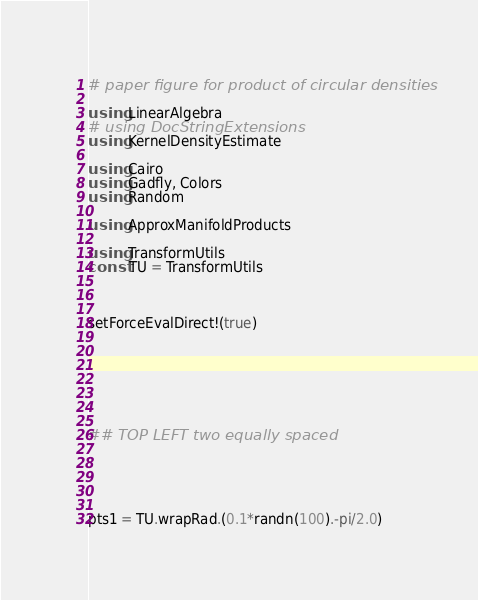Convert code to text. <code><loc_0><loc_0><loc_500><loc_500><_Julia_># paper figure for product of circular densities

using LinearAlgebra
# using DocStringExtensions
using KernelDensityEstimate

using Cairo
using Gadfly, Colors
using Random

using ApproxManifoldProducts

using TransformUtils
const TU = TransformUtils



setForceEvalDirect!(true)







## TOP LEFT two equally spaced





pts1 = TU.wrapRad.(0.1*randn(100).-pi/2.0)</code> 